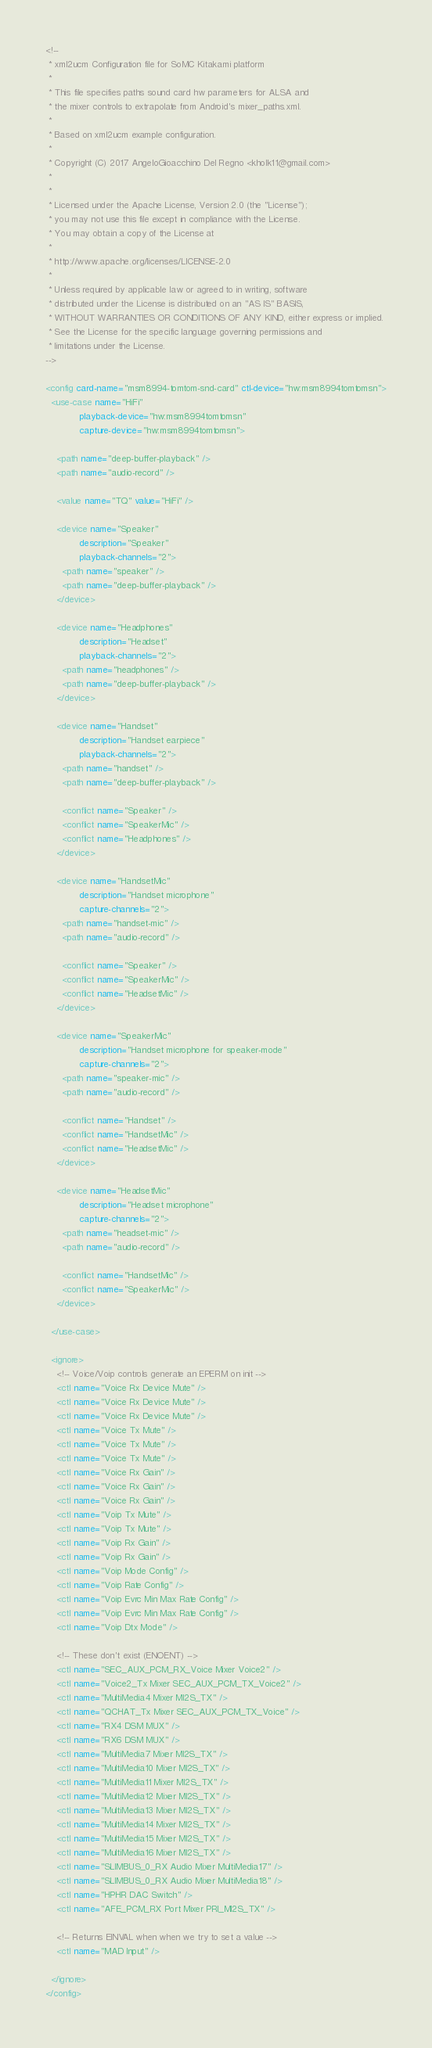<code> <loc_0><loc_0><loc_500><loc_500><_XML_><!--
 * xml2ucm Configuration file for SoMC Kitakami platform
 *
 * This file specifies paths sound card hw parameters for ALSA and
 * the mixer controls to extrapolate from Android's mixer_paths.xml.
 *
 * Based on xml2ucm example configuration.
 *
 * Copyright (C) 2017 AngeloGioacchino Del Regno <kholk11@gmail.com>
 *
 *
 * Licensed under the Apache License, Version 2.0 (the "License");
 * you may not use this file except in compliance with the License.
 * You may obtain a copy of the License at
 *
 * http://www.apache.org/licenses/LICENSE-2.0
 *
 * Unless required by applicable law or agreed to in writing, software
 * distributed under the License is distributed on an "AS IS" BASIS,
 * WITHOUT WARRANTIES OR CONDITIONS OF ANY KIND, either express or implied.
 * See the License for the specific language governing permissions and
 * limitations under the License.
-->

<config card-name="msm8994-tomtom-snd-card" ctl-device="hw:msm8994tomtomsn">
  <use-case name="HiFi"
            playback-device="hw:msm8994tomtomsn"
            capture-device="hw:msm8994tomtomsn">

    <path name="deep-buffer-playback" />
    <path name="audio-record" />

    <value name="TQ" value="HiFi" />

    <device name="Speaker"
            description="Speaker"
            playback-channels="2">
      <path name="speaker" />
      <path name="deep-buffer-playback" />
    </device>

    <device name="Headphones"
            description="Headset"
            playback-channels="2">
      <path name="headphones" />
      <path name="deep-buffer-playback" />
    </device>

    <device name="Handset"
            description="Handset earpiece"
            playback-channels="2">
      <path name="handset" />
      <path name="deep-buffer-playback" />

      <conflict name="Speaker" />
      <conflict name="SpeakerMic" />
      <conflict name="Headphones" />
    </device>

    <device name="HandsetMic"
            description="Handset microphone"
            capture-channels="2">
      <path name="handset-mic" />
      <path name="audio-record" />

      <conflict name="Speaker" />
      <conflict name="SpeakerMic" />
      <conflict name="HeadsetMic" />
    </device>

    <device name="SpeakerMic"
            description="Handset microphone for speaker-mode"
            capture-channels="2">
      <path name="speaker-mic" />
      <path name="audio-record" />

      <conflict name="Handset" />
      <conflict name="HandsetMic" />
      <conflict name="HeadsetMic" />
    </device>

    <device name="HeadsetMic"
            description="Headset microphone"
            capture-channels="2">
      <path name="headset-mic" />
      <path name="audio-record" />

      <conflict name="HandsetMic" />
      <conflict name="SpeakerMic" />
    </device>

  </use-case>

  <ignore>
    <!-- Voice/Voip controls generate an EPERM on init -->
    <ctl name="Voice Rx Device Mute" />
    <ctl name="Voice Rx Device Mute" />
    <ctl name="Voice Rx Device Mute" />
    <ctl name="Voice Tx Mute" />
    <ctl name="Voice Tx Mute" />
    <ctl name="Voice Tx Mute" />
    <ctl name="Voice Rx Gain" />
    <ctl name="Voice Rx Gain" />
    <ctl name="Voice Rx Gain" />
    <ctl name="Voip Tx Mute" />
    <ctl name="Voip Tx Mute" />
    <ctl name="Voip Rx Gain" />
    <ctl name="Voip Rx Gain" />
    <ctl name="Voip Mode Config" />
    <ctl name="Voip Rate Config" />
    <ctl name="Voip Evrc Min Max Rate Config" />
    <ctl name="Voip Evrc Min Max Rate Config" />
    <ctl name="Voip Dtx Mode" />

    <!-- These don't exist (ENOENT) -->
    <ctl name="SEC_AUX_PCM_RX_Voice Mixer Voice2" />
    <ctl name="Voice2_Tx Mixer SEC_AUX_PCM_TX_Voice2" />
    <ctl name="MultiMedia4 Mixer MI2S_TX" />
    <ctl name="QCHAT_Tx Mixer SEC_AUX_PCM_TX_Voice" />
    <ctl name="RX4 DSM MUX" />
    <ctl name="RX6 DSM MUX" />
    <ctl name="MultiMedia7 Mixer MI2S_TX" />
    <ctl name="MultiMedia10 Mixer MI2S_TX" />
    <ctl name="MultiMedia11 Mixer MI2S_TX" />
    <ctl name="MultiMedia12 Mixer MI2S_TX" />
    <ctl name="MultiMedia13 Mixer MI2S_TX" />
    <ctl name="MultiMedia14 Mixer MI2S_TX" />
    <ctl name="MultiMedia15 Mixer MI2S_TX" />
    <ctl name="MultiMedia16 Mixer MI2S_TX" />
    <ctl name="SLIMBUS_0_RX Audio Mixer MultiMedia17" />
    <ctl name="SLIMBUS_0_RX Audio Mixer MultiMedia18" />
    <ctl name="HPHR DAC Switch" />
    <ctl name="AFE_PCM_RX Port Mixer PRI_MI2S_TX" />

    <!-- Returns EINVAL when when we try to set a value -->
    <ctl name="MAD Input" />

  </ignore>
</config>
</code> 